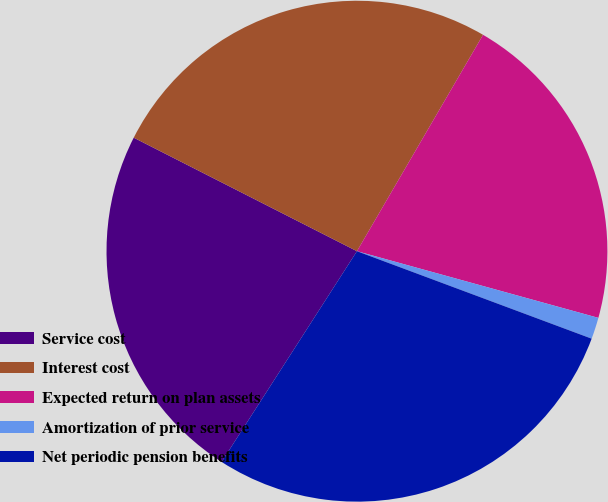Convert chart. <chart><loc_0><loc_0><loc_500><loc_500><pie_chart><fcel>Service cost<fcel>Interest cost<fcel>Expected return on plan assets<fcel>Amortization of prior service<fcel>Net periodic pension benefits<nl><fcel>23.4%<fcel>25.91%<fcel>20.89%<fcel>1.39%<fcel>28.41%<nl></chart> 